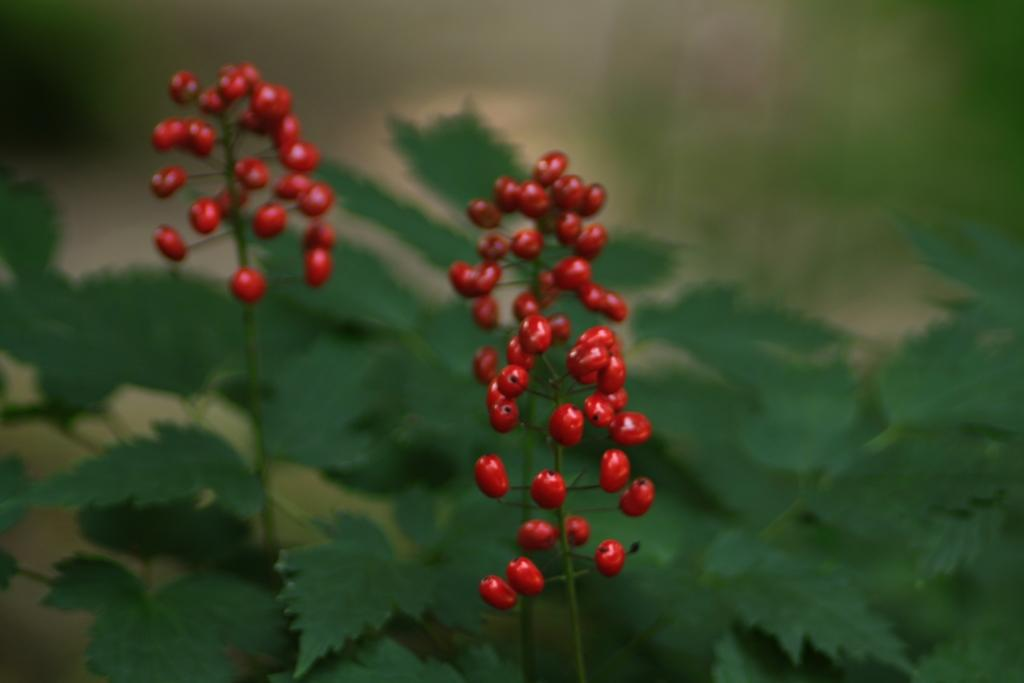What type of berries can be seen in the image? There are red color berries in the image. What color are the leaves in the image? There are green color leaves in the image. How would you describe the background of the image? The background of the image is blurry. What type of beast can be seen walking on the sidewalk in the image? There is no beast or sidewalk present in the image; it features red berries and green leaves with a blurry background. 